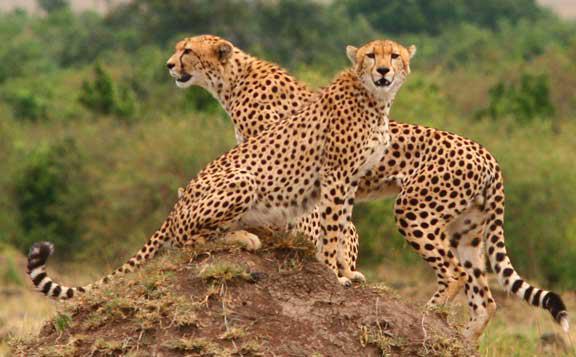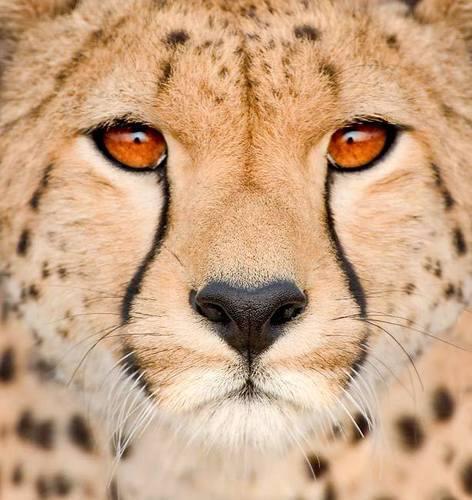The first image is the image on the left, the second image is the image on the right. Assess this claim about the two images: "At least one of the animals is sitting on the ground.". Correct or not? Answer yes or no. Yes. The first image is the image on the left, the second image is the image on the right. For the images displayed, is the sentence "Each image shows a single spotted wild cat, and each cat is in a similar type of pose." factually correct? Answer yes or no. No. 